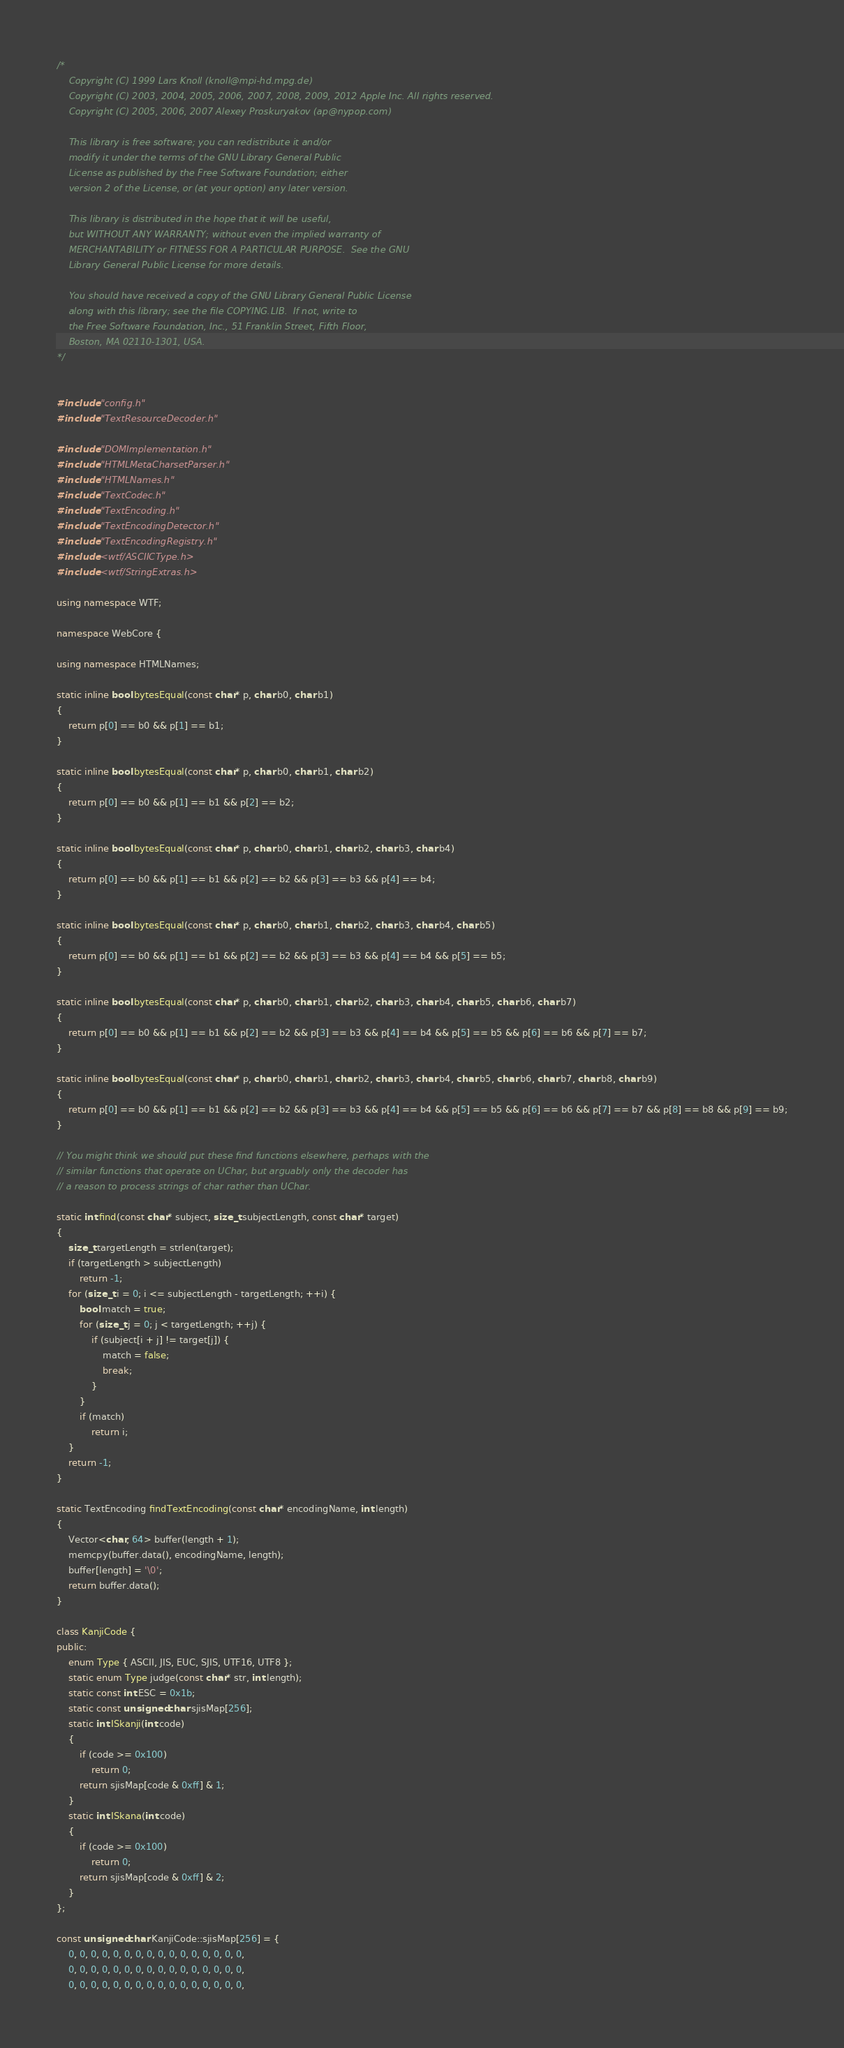<code> <loc_0><loc_0><loc_500><loc_500><_C++_>/*
    Copyright (C) 1999 Lars Knoll (knoll@mpi-hd.mpg.de)
    Copyright (C) 2003, 2004, 2005, 2006, 2007, 2008, 2009, 2012 Apple Inc. All rights reserved.
    Copyright (C) 2005, 2006, 2007 Alexey Proskuryakov (ap@nypop.com)

    This library is free software; you can redistribute it and/or
    modify it under the terms of the GNU Library General Public
    License as published by the Free Software Foundation; either
    version 2 of the License, or (at your option) any later version.

    This library is distributed in the hope that it will be useful,
    but WITHOUT ANY WARRANTY; without even the implied warranty of
    MERCHANTABILITY or FITNESS FOR A PARTICULAR PURPOSE.  See the GNU
    Library General Public License for more details.

    You should have received a copy of the GNU Library General Public License
    along with this library; see the file COPYING.LIB.  If not, write to
    the Free Software Foundation, Inc., 51 Franklin Street, Fifth Floor,
    Boston, MA 02110-1301, USA.
*/


#include "config.h"
#include "TextResourceDecoder.h"

#include "DOMImplementation.h"
#include "HTMLMetaCharsetParser.h"
#include "HTMLNames.h"
#include "TextCodec.h"
#include "TextEncoding.h"
#include "TextEncodingDetector.h"
#include "TextEncodingRegistry.h"
#include <wtf/ASCIICType.h>
#include <wtf/StringExtras.h>

using namespace WTF;

namespace WebCore {

using namespace HTMLNames;

static inline bool bytesEqual(const char* p, char b0, char b1)
{
    return p[0] == b0 && p[1] == b1;
}

static inline bool bytesEqual(const char* p, char b0, char b1, char b2)
{
    return p[0] == b0 && p[1] == b1 && p[2] == b2;
}

static inline bool bytesEqual(const char* p, char b0, char b1, char b2, char b3, char b4)
{
    return p[0] == b0 && p[1] == b1 && p[2] == b2 && p[3] == b3 && p[4] == b4;
}

static inline bool bytesEqual(const char* p, char b0, char b1, char b2, char b3, char b4, char b5)
{
    return p[0] == b0 && p[1] == b1 && p[2] == b2 && p[3] == b3 && p[4] == b4 && p[5] == b5;
}

static inline bool bytesEqual(const char* p, char b0, char b1, char b2, char b3, char b4, char b5, char b6, char b7)
{
    return p[0] == b0 && p[1] == b1 && p[2] == b2 && p[3] == b3 && p[4] == b4 && p[5] == b5 && p[6] == b6 && p[7] == b7;
}

static inline bool bytesEqual(const char* p, char b0, char b1, char b2, char b3, char b4, char b5, char b6, char b7, char b8, char b9)
{
    return p[0] == b0 && p[1] == b1 && p[2] == b2 && p[3] == b3 && p[4] == b4 && p[5] == b5 && p[6] == b6 && p[7] == b7 && p[8] == b8 && p[9] == b9;
}

// You might think we should put these find functions elsewhere, perhaps with the
// similar functions that operate on UChar, but arguably only the decoder has
// a reason to process strings of char rather than UChar.

static int find(const char* subject, size_t subjectLength, const char* target)
{
    size_t targetLength = strlen(target);
    if (targetLength > subjectLength)
        return -1;
    for (size_t i = 0; i <= subjectLength - targetLength; ++i) {
        bool match = true;
        for (size_t j = 0; j < targetLength; ++j) {
            if (subject[i + j] != target[j]) {
                match = false;
                break;
            }
        }
        if (match)
            return i;
    }
    return -1;
}

static TextEncoding findTextEncoding(const char* encodingName, int length)
{
    Vector<char, 64> buffer(length + 1);
    memcpy(buffer.data(), encodingName, length);
    buffer[length] = '\0';
    return buffer.data();
}

class KanjiCode {
public:
    enum Type { ASCII, JIS, EUC, SJIS, UTF16, UTF8 };
    static enum Type judge(const char* str, int length);
    static const int ESC = 0x1b;
    static const unsigned char sjisMap[256];
    static int ISkanji(int code)
    {
        if (code >= 0x100)
            return 0;
        return sjisMap[code & 0xff] & 1;
    }
    static int ISkana(int code)
    {
        if (code >= 0x100)
            return 0;
        return sjisMap[code & 0xff] & 2;
    }
};

const unsigned char KanjiCode::sjisMap[256] = {
    0, 0, 0, 0, 0, 0, 0, 0, 0, 0, 0, 0, 0, 0, 0, 0,
    0, 0, 0, 0, 0, 0, 0, 0, 0, 0, 0, 0, 0, 0, 0, 0,
    0, 0, 0, 0, 0, 0, 0, 0, 0, 0, 0, 0, 0, 0, 0, 0,</code> 